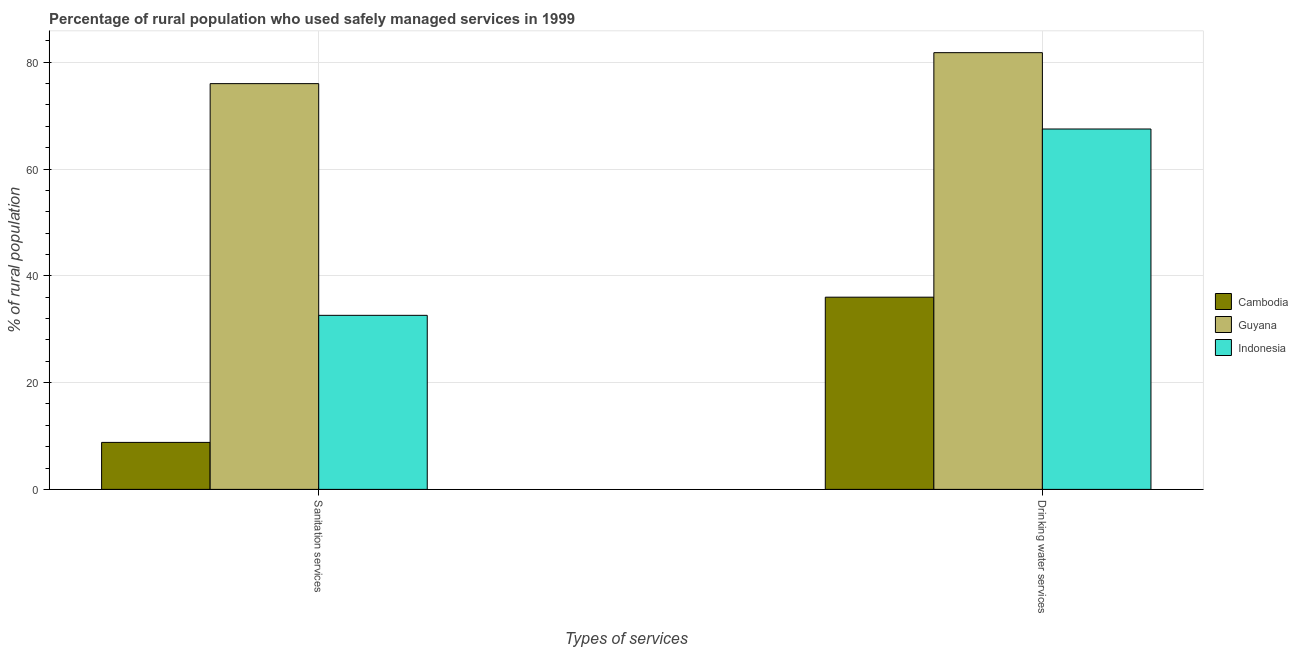How many bars are there on the 1st tick from the left?
Your answer should be compact. 3. What is the label of the 2nd group of bars from the left?
Make the answer very short. Drinking water services. Across all countries, what is the maximum percentage of rural population who used drinking water services?
Make the answer very short. 81.8. Across all countries, what is the minimum percentage of rural population who used drinking water services?
Ensure brevity in your answer.  36. In which country was the percentage of rural population who used sanitation services maximum?
Your response must be concise. Guyana. In which country was the percentage of rural population who used sanitation services minimum?
Your answer should be compact. Cambodia. What is the total percentage of rural population who used drinking water services in the graph?
Your answer should be very brief. 185.3. What is the difference between the percentage of rural population who used drinking water services in Guyana and that in Indonesia?
Keep it short and to the point. 14.3. What is the difference between the percentage of rural population who used drinking water services in Indonesia and the percentage of rural population who used sanitation services in Guyana?
Offer a terse response. -8.5. What is the average percentage of rural population who used drinking water services per country?
Provide a short and direct response. 61.77. What is the difference between the percentage of rural population who used drinking water services and percentage of rural population who used sanitation services in Cambodia?
Provide a short and direct response. 27.2. What is the ratio of the percentage of rural population who used drinking water services in Guyana to that in Cambodia?
Provide a succinct answer. 2.27. Is the percentage of rural population who used sanitation services in Guyana less than that in Cambodia?
Ensure brevity in your answer.  No. In how many countries, is the percentage of rural population who used drinking water services greater than the average percentage of rural population who used drinking water services taken over all countries?
Your response must be concise. 2. What does the 2nd bar from the left in Sanitation services represents?
Offer a terse response. Guyana. What does the 2nd bar from the right in Sanitation services represents?
Your response must be concise. Guyana. How many bars are there?
Keep it short and to the point. 6. Are all the bars in the graph horizontal?
Ensure brevity in your answer.  No. What is the difference between two consecutive major ticks on the Y-axis?
Your answer should be very brief. 20. Does the graph contain any zero values?
Give a very brief answer. No. Where does the legend appear in the graph?
Make the answer very short. Center right. How many legend labels are there?
Ensure brevity in your answer.  3. What is the title of the graph?
Keep it short and to the point. Percentage of rural population who used safely managed services in 1999. Does "Brunei Darussalam" appear as one of the legend labels in the graph?
Provide a succinct answer. No. What is the label or title of the X-axis?
Your answer should be very brief. Types of services. What is the label or title of the Y-axis?
Provide a succinct answer. % of rural population. What is the % of rural population in Indonesia in Sanitation services?
Provide a short and direct response. 32.6. What is the % of rural population of Cambodia in Drinking water services?
Offer a very short reply. 36. What is the % of rural population of Guyana in Drinking water services?
Ensure brevity in your answer.  81.8. What is the % of rural population of Indonesia in Drinking water services?
Offer a terse response. 67.5. Across all Types of services, what is the maximum % of rural population in Guyana?
Ensure brevity in your answer.  81.8. Across all Types of services, what is the maximum % of rural population in Indonesia?
Ensure brevity in your answer.  67.5. Across all Types of services, what is the minimum % of rural population of Guyana?
Your answer should be very brief. 76. Across all Types of services, what is the minimum % of rural population of Indonesia?
Provide a succinct answer. 32.6. What is the total % of rural population of Cambodia in the graph?
Make the answer very short. 44.8. What is the total % of rural population in Guyana in the graph?
Give a very brief answer. 157.8. What is the total % of rural population of Indonesia in the graph?
Your answer should be very brief. 100.1. What is the difference between the % of rural population of Cambodia in Sanitation services and that in Drinking water services?
Offer a very short reply. -27.2. What is the difference between the % of rural population in Indonesia in Sanitation services and that in Drinking water services?
Make the answer very short. -34.9. What is the difference between the % of rural population of Cambodia in Sanitation services and the % of rural population of Guyana in Drinking water services?
Your answer should be very brief. -73. What is the difference between the % of rural population of Cambodia in Sanitation services and the % of rural population of Indonesia in Drinking water services?
Provide a short and direct response. -58.7. What is the difference between the % of rural population of Guyana in Sanitation services and the % of rural population of Indonesia in Drinking water services?
Offer a very short reply. 8.5. What is the average % of rural population of Cambodia per Types of services?
Your response must be concise. 22.4. What is the average % of rural population in Guyana per Types of services?
Offer a very short reply. 78.9. What is the average % of rural population in Indonesia per Types of services?
Your answer should be compact. 50.05. What is the difference between the % of rural population of Cambodia and % of rural population of Guyana in Sanitation services?
Offer a terse response. -67.2. What is the difference between the % of rural population in Cambodia and % of rural population in Indonesia in Sanitation services?
Offer a terse response. -23.8. What is the difference between the % of rural population of Guyana and % of rural population of Indonesia in Sanitation services?
Your answer should be very brief. 43.4. What is the difference between the % of rural population in Cambodia and % of rural population in Guyana in Drinking water services?
Give a very brief answer. -45.8. What is the difference between the % of rural population of Cambodia and % of rural population of Indonesia in Drinking water services?
Your answer should be compact. -31.5. What is the difference between the % of rural population in Guyana and % of rural population in Indonesia in Drinking water services?
Ensure brevity in your answer.  14.3. What is the ratio of the % of rural population in Cambodia in Sanitation services to that in Drinking water services?
Offer a very short reply. 0.24. What is the ratio of the % of rural population in Guyana in Sanitation services to that in Drinking water services?
Ensure brevity in your answer.  0.93. What is the ratio of the % of rural population in Indonesia in Sanitation services to that in Drinking water services?
Keep it short and to the point. 0.48. What is the difference between the highest and the second highest % of rural population in Cambodia?
Ensure brevity in your answer.  27.2. What is the difference between the highest and the second highest % of rural population of Guyana?
Provide a short and direct response. 5.8. What is the difference between the highest and the second highest % of rural population of Indonesia?
Keep it short and to the point. 34.9. What is the difference between the highest and the lowest % of rural population of Cambodia?
Provide a succinct answer. 27.2. What is the difference between the highest and the lowest % of rural population in Indonesia?
Your answer should be very brief. 34.9. 